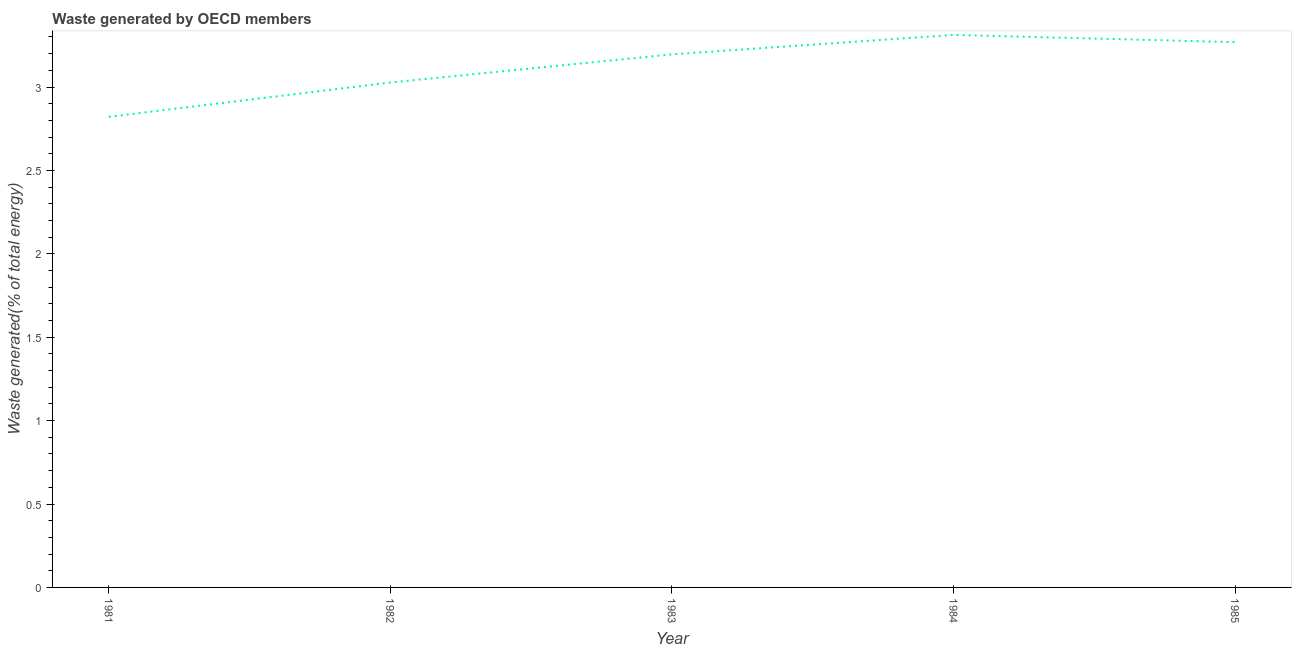What is the amount of waste generated in 1981?
Ensure brevity in your answer.  2.82. Across all years, what is the maximum amount of waste generated?
Give a very brief answer. 3.31. Across all years, what is the minimum amount of waste generated?
Make the answer very short. 2.82. What is the sum of the amount of waste generated?
Keep it short and to the point. 15.63. What is the difference between the amount of waste generated in 1982 and 1984?
Offer a terse response. -0.29. What is the average amount of waste generated per year?
Make the answer very short. 3.13. What is the median amount of waste generated?
Offer a very short reply. 3.2. What is the ratio of the amount of waste generated in 1982 to that in 1985?
Your response must be concise. 0.93. What is the difference between the highest and the second highest amount of waste generated?
Offer a very short reply. 0.04. What is the difference between the highest and the lowest amount of waste generated?
Keep it short and to the point. 0.49. In how many years, is the amount of waste generated greater than the average amount of waste generated taken over all years?
Ensure brevity in your answer.  3. Does the amount of waste generated monotonically increase over the years?
Your answer should be compact. No. How many years are there in the graph?
Offer a terse response. 5. Does the graph contain any zero values?
Offer a terse response. No. What is the title of the graph?
Offer a terse response. Waste generated by OECD members. What is the label or title of the Y-axis?
Offer a terse response. Waste generated(% of total energy). What is the Waste generated(% of total energy) of 1981?
Ensure brevity in your answer.  2.82. What is the Waste generated(% of total energy) in 1982?
Keep it short and to the point. 3.03. What is the Waste generated(% of total energy) of 1983?
Offer a very short reply. 3.2. What is the Waste generated(% of total energy) of 1984?
Your answer should be very brief. 3.31. What is the Waste generated(% of total energy) of 1985?
Keep it short and to the point. 3.27. What is the difference between the Waste generated(% of total energy) in 1981 and 1982?
Your response must be concise. -0.21. What is the difference between the Waste generated(% of total energy) in 1981 and 1983?
Provide a short and direct response. -0.37. What is the difference between the Waste generated(% of total energy) in 1981 and 1984?
Offer a terse response. -0.49. What is the difference between the Waste generated(% of total energy) in 1981 and 1985?
Offer a very short reply. -0.45. What is the difference between the Waste generated(% of total energy) in 1982 and 1983?
Your answer should be very brief. -0.17. What is the difference between the Waste generated(% of total energy) in 1982 and 1984?
Keep it short and to the point. -0.29. What is the difference between the Waste generated(% of total energy) in 1982 and 1985?
Provide a succinct answer. -0.24. What is the difference between the Waste generated(% of total energy) in 1983 and 1984?
Your answer should be very brief. -0.12. What is the difference between the Waste generated(% of total energy) in 1983 and 1985?
Your response must be concise. -0.07. What is the difference between the Waste generated(% of total energy) in 1984 and 1985?
Ensure brevity in your answer.  0.04. What is the ratio of the Waste generated(% of total energy) in 1981 to that in 1982?
Offer a very short reply. 0.93. What is the ratio of the Waste generated(% of total energy) in 1981 to that in 1983?
Your answer should be compact. 0.88. What is the ratio of the Waste generated(% of total energy) in 1981 to that in 1984?
Your answer should be compact. 0.85. What is the ratio of the Waste generated(% of total energy) in 1981 to that in 1985?
Give a very brief answer. 0.86. What is the ratio of the Waste generated(% of total energy) in 1982 to that in 1983?
Provide a short and direct response. 0.95. What is the ratio of the Waste generated(% of total energy) in 1982 to that in 1984?
Keep it short and to the point. 0.91. What is the ratio of the Waste generated(% of total energy) in 1982 to that in 1985?
Your answer should be compact. 0.93. 